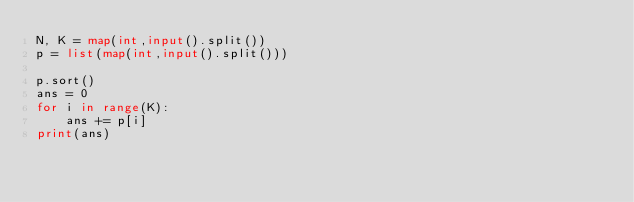Convert code to text. <code><loc_0><loc_0><loc_500><loc_500><_Python_>N, K = map(int,input().split())
p = list(map(int,input().split()))

p.sort()
ans = 0
for i in range(K):
    ans += p[i]
print(ans)</code> 